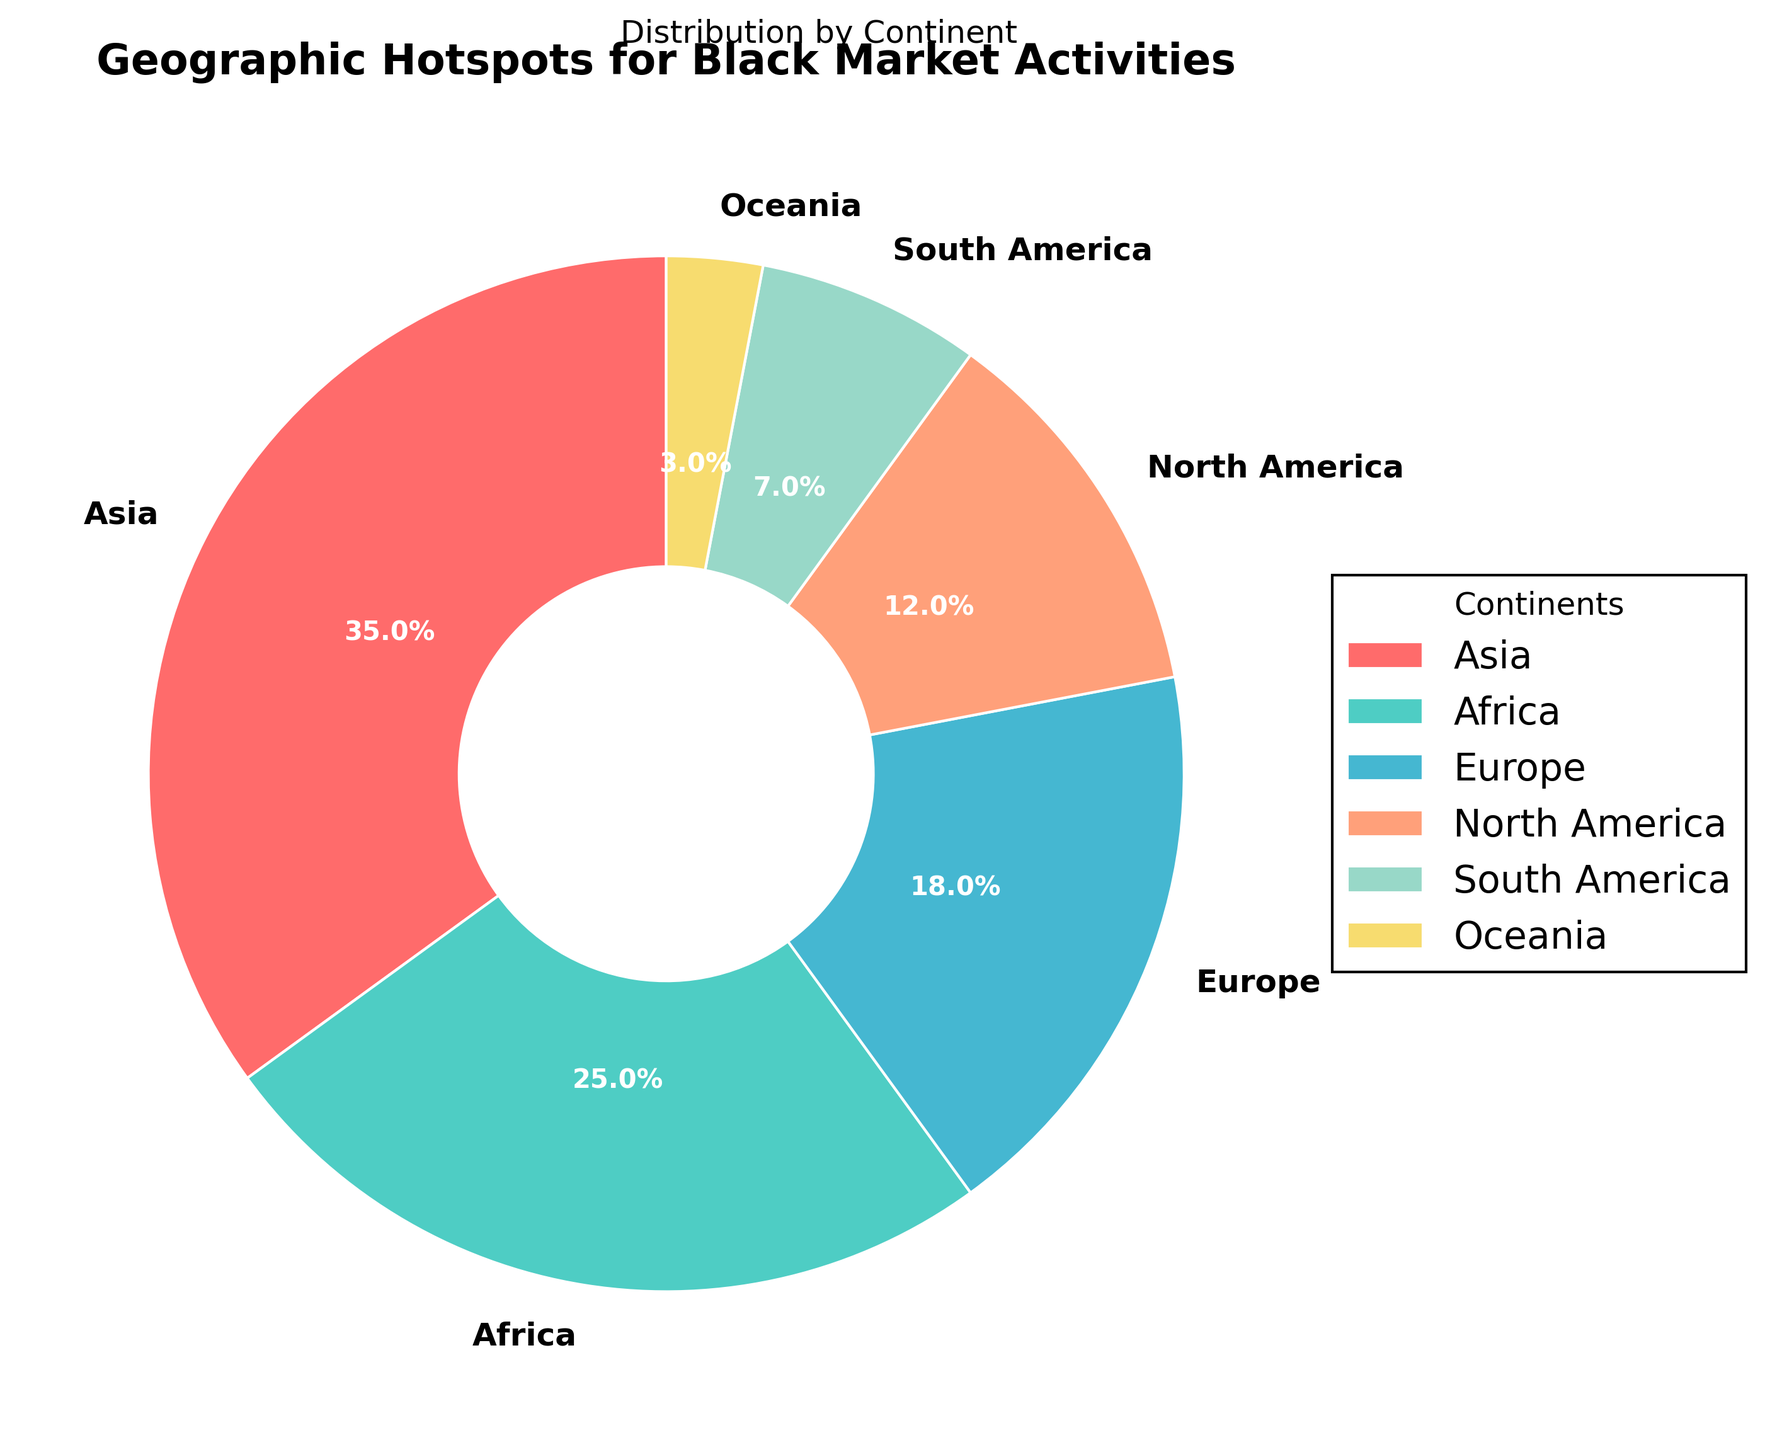What is the continent with the highest percentage of black market activities? To identify the continent with the highest percentage, look at the pie chart and find the largest segment. The largest segment is Asia with 35%.
Answer: Asia What is the combined percentage of black market activities in Europe and North America? First, identify the percentages for Europe and North America from the pie chart. Europe is 18% and North America is 12%. Summing them up: 18% + 12% = 30%.
Answer: 30% Which continent has the lowest percentage of black market activities? Determine the smallest segment in the pie chart, which represents the smallest percentage. The smallest segment is Oceania with 3%.
Answer: Oceania How much greater is the percentage of black market activities in Asia compared to South America? Find the percentages for Asia and South America from the pie chart. Asia is 35% and South America is 7%. Subtract South America's percentage from Asia's: 35% - 7% = 28%.
Answer: 28% Arrange the continents in descending order of their percentage of black market activities. Look at the percentages in the pie chart and arrange them from largest to smallest: Asia (35%), Africa (25%), Europe (18%), North America (12%), South America (7%), Oceania (3%).
Answer: Asia, Africa, Europe, North America, South America, Oceania What is the total percentage of black market activities in continents other than Asia? Asia's percentage is 35%. The total percentage from all other continents is 100% - 35% = 65%.
Answer: 65% Is the percentage of black market activities in Africa more than double that in Oceania? Africa has 25% and Oceania has 3%. Double Oceania's percentage is 3% * 2 = 6%. Since 25% > 6%, Africa's percentage is indeed more than double that in Oceania.
Answer: Yes Which continents together constitute exactly half of the black market activities? Identify combinations of continents that sum up to 50%. Europe (18%) + North America (12%) + South America (7%) + Oceania (3%) adds up to 40%, and Asia (35%) + South America (7%) + Oceania (3%) adds up to 45%. The correct combination is Africa (25%) and Europe (18%) + North America (12%) = 55%, which is closest but slightly more. So, there is no exact combination for 50%.
Answer: None 